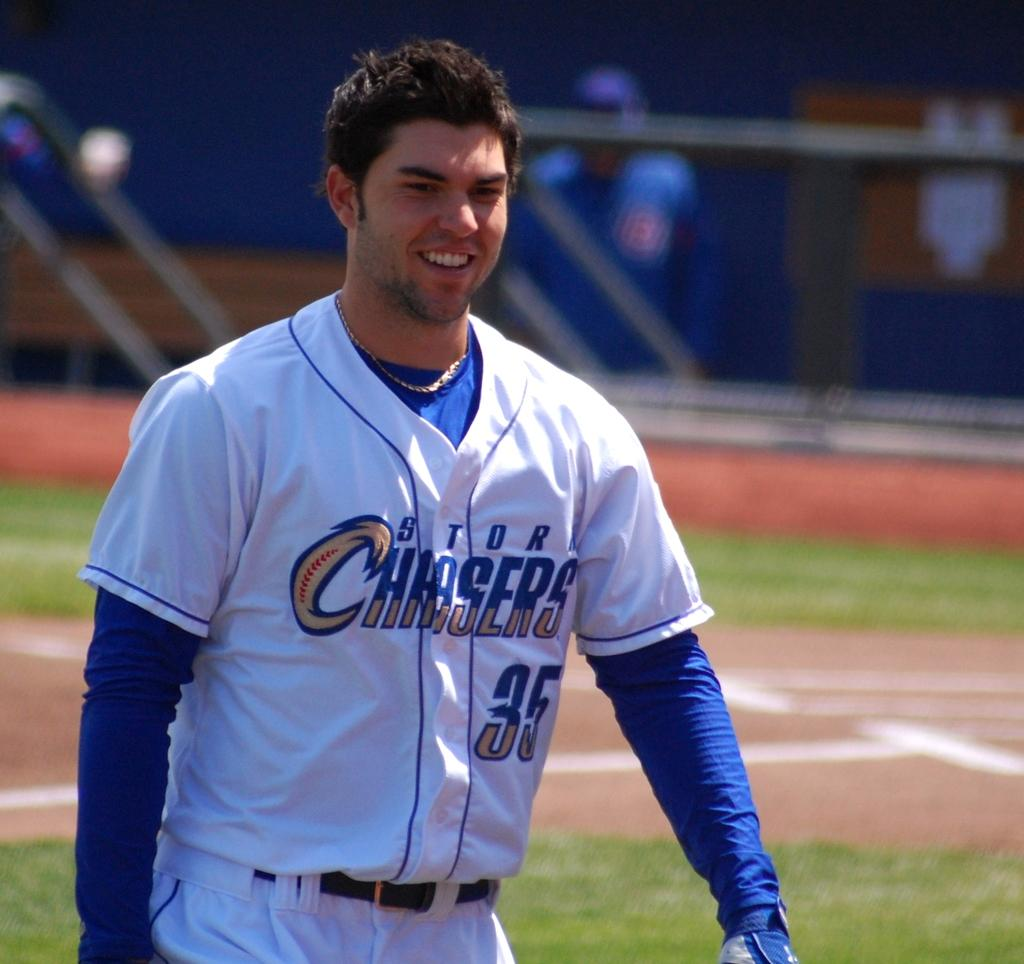<image>
Describe the image concisely. A baseball player is dressed in a Storm Chasers uniform. 